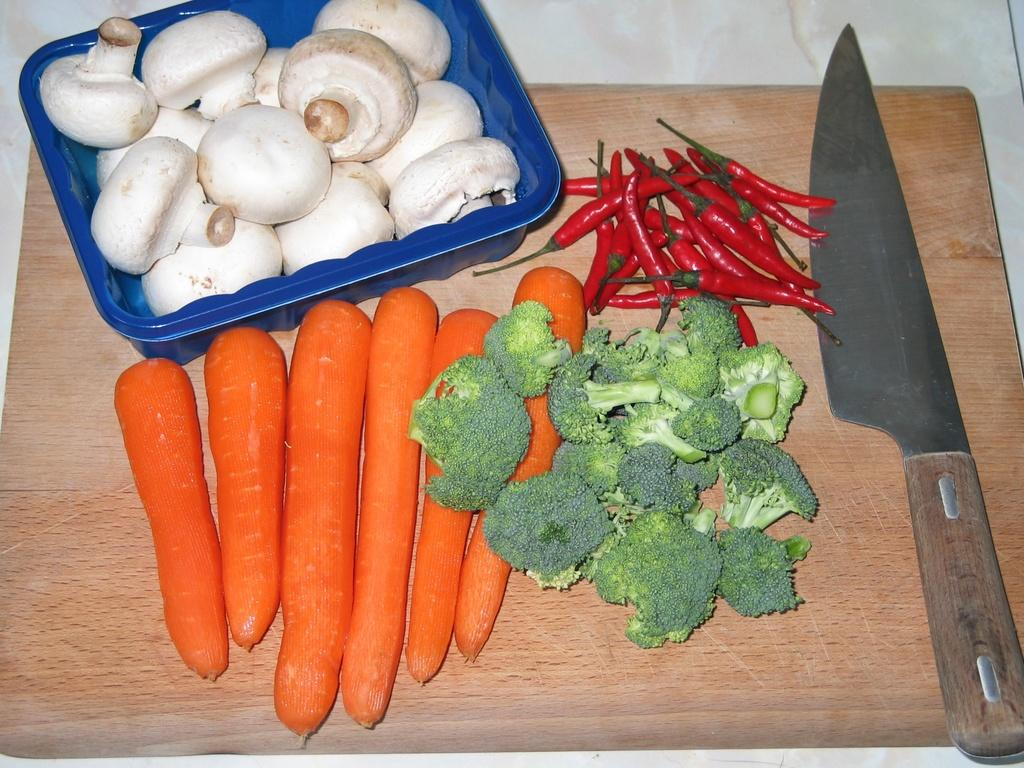What material is the sheet in the image made of? The sheet in the image is made of wood. What items can be found on the wooden sheet? The wooden sheet contains a knife, chili's, broccoli, and carrots. What is located in the container in the image? The container contains mushrooms. What type of coast can be seen in the image? There is no coast present in the image; it features a wooden sheet with various food items and a container with mushrooms. 